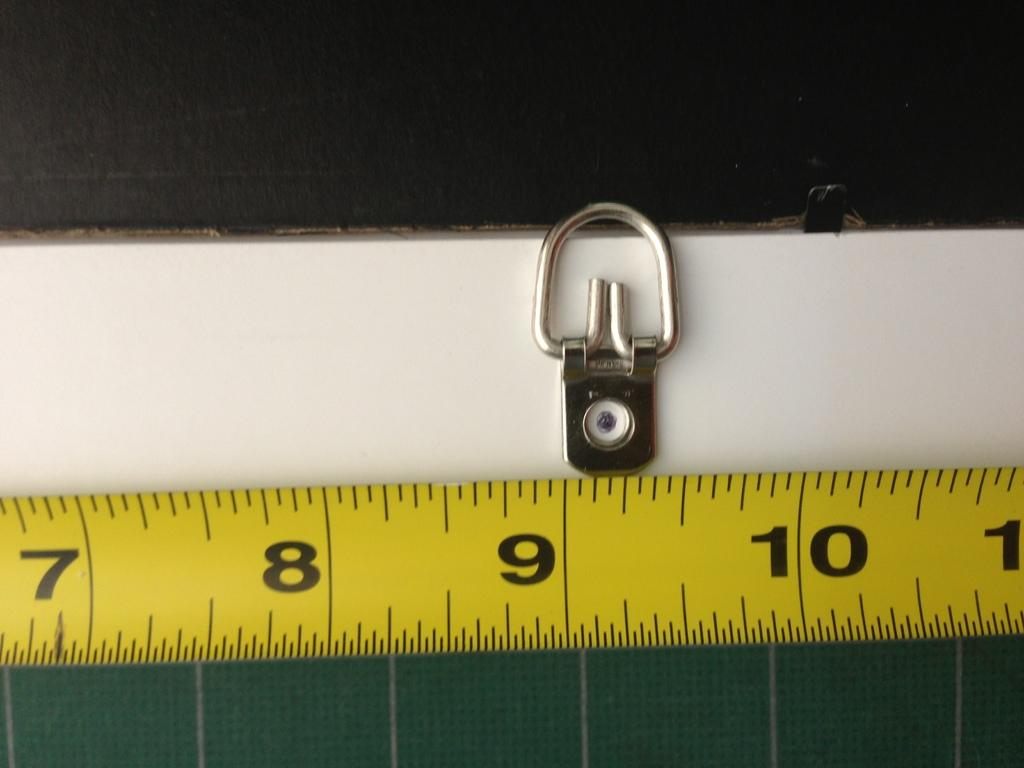<image>
Summarize the visual content of the image. A yellow metal retractable tape measure showing 7 through 10. 